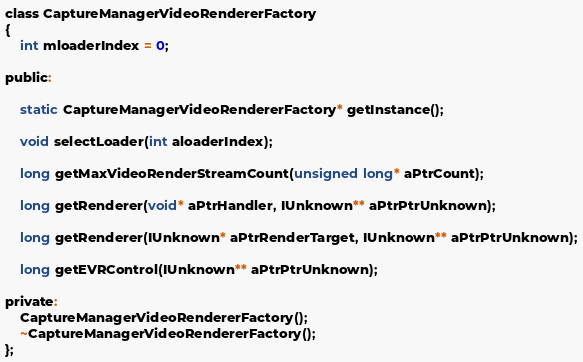<code> <loc_0><loc_0><loc_500><loc_500><_C_>
class CaptureManagerVideoRendererFactory
{
	int mloaderIndex = 0;

public:

	static CaptureManagerVideoRendererFactory* getInstance();

	void selectLoader(int aloaderIndex);

	long getMaxVideoRenderStreamCount(unsigned long* aPtrCount);

	long getRenderer(void* aPtrHandler, IUnknown** aPtrPtrUnknown);

	long getRenderer(IUnknown* aPtrRenderTarget, IUnknown** aPtrPtrUnknown);

	long getEVRControl(IUnknown** aPtrPtrUnknown);

private:
	CaptureManagerVideoRendererFactory();
	~CaptureManagerVideoRendererFactory();
};

</code> 